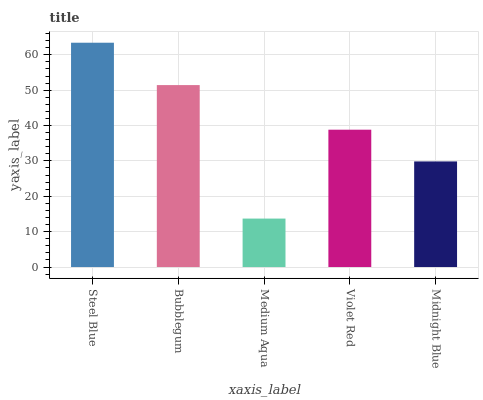Is Medium Aqua the minimum?
Answer yes or no. Yes. Is Steel Blue the maximum?
Answer yes or no. Yes. Is Bubblegum the minimum?
Answer yes or no. No. Is Bubblegum the maximum?
Answer yes or no. No. Is Steel Blue greater than Bubblegum?
Answer yes or no. Yes. Is Bubblegum less than Steel Blue?
Answer yes or no. Yes. Is Bubblegum greater than Steel Blue?
Answer yes or no. No. Is Steel Blue less than Bubblegum?
Answer yes or no. No. Is Violet Red the high median?
Answer yes or no. Yes. Is Violet Red the low median?
Answer yes or no. Yes. Is Midnight Blue the high median?
Answer yes or no. No. Is Bubblegum the low median?
Answer yes or no. No. 